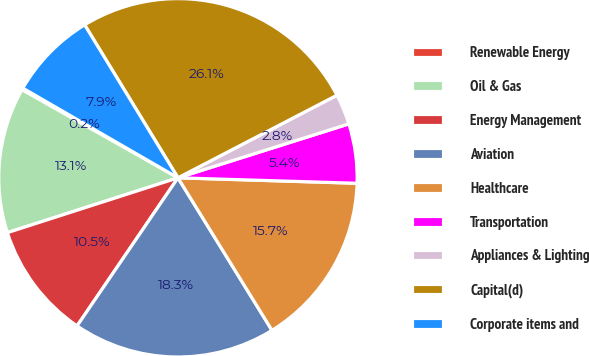<chart> <loc_0><loc_0><loc_500><loc_500><pie_chart><fcel>Renewable Energy<fcel>Oil & Gas<fcel>Energy Management<fcel>Aviation<fcel>Healthcare<fcel>Transportation<fcel>Appliances & Lighting<fcel>Capital(d)<fcel>Corporate items and<nl><fcel>0.16%<fcel>13.13%<fcel>10.53%<fcel>18.31%<fcel>15.72%<fcel>5.35%<fcel>2.76%<fcel>26.09%<fcel>7.94%<nl></chart> 